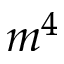Convert formula to latex. <formula><loc_0><loc_0><loc_500><loc_500>m ^ { 4 }</formula> 